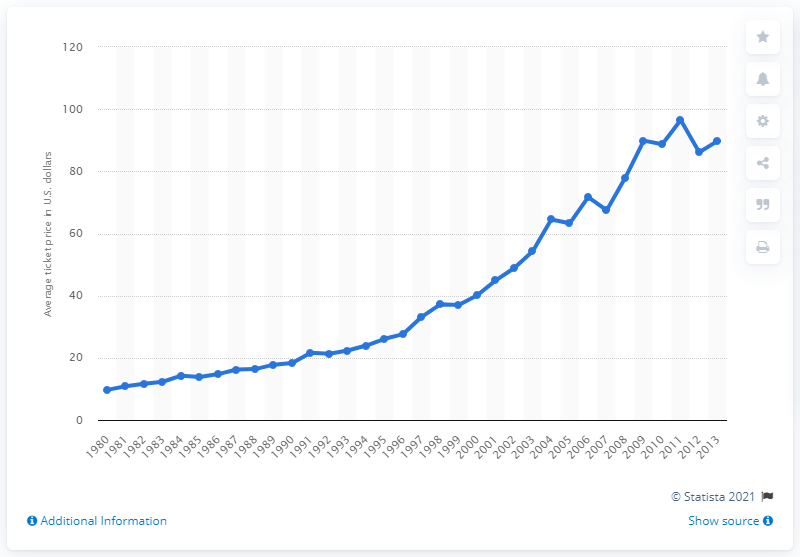Give some essential details in this illustration. In 2010, the average ticket price was 88.69. 